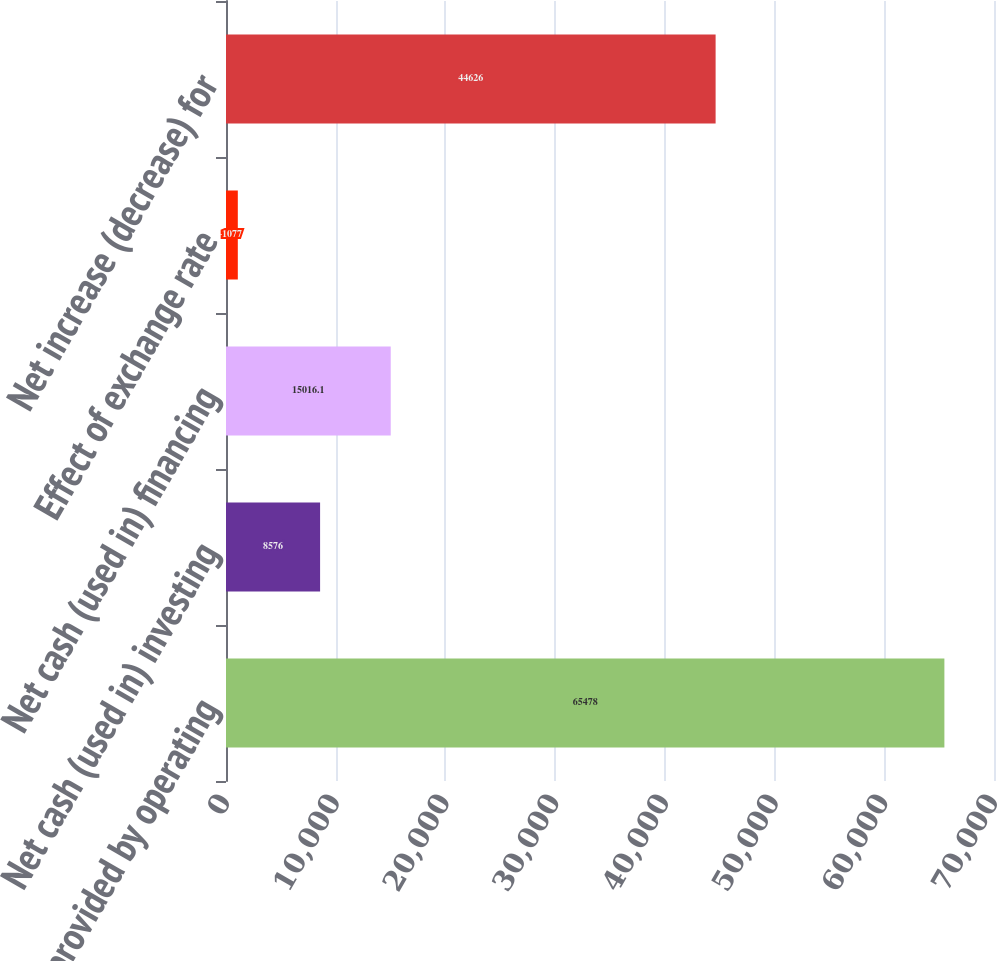<chart> <loc_0><loc_0><loc_500><loc_500><bar_chart><fcel>Net cash provided by operating<fcel>Net cash (used in) investing<fcel>Net cash (used in) financing<fcel>Effect of exchange rate<fcel>Net increase (decrease) for<nl><fcel>65478<fcel>8576<fcel>15016.1<fcel>1077<fcel>44626<nl></chart> 